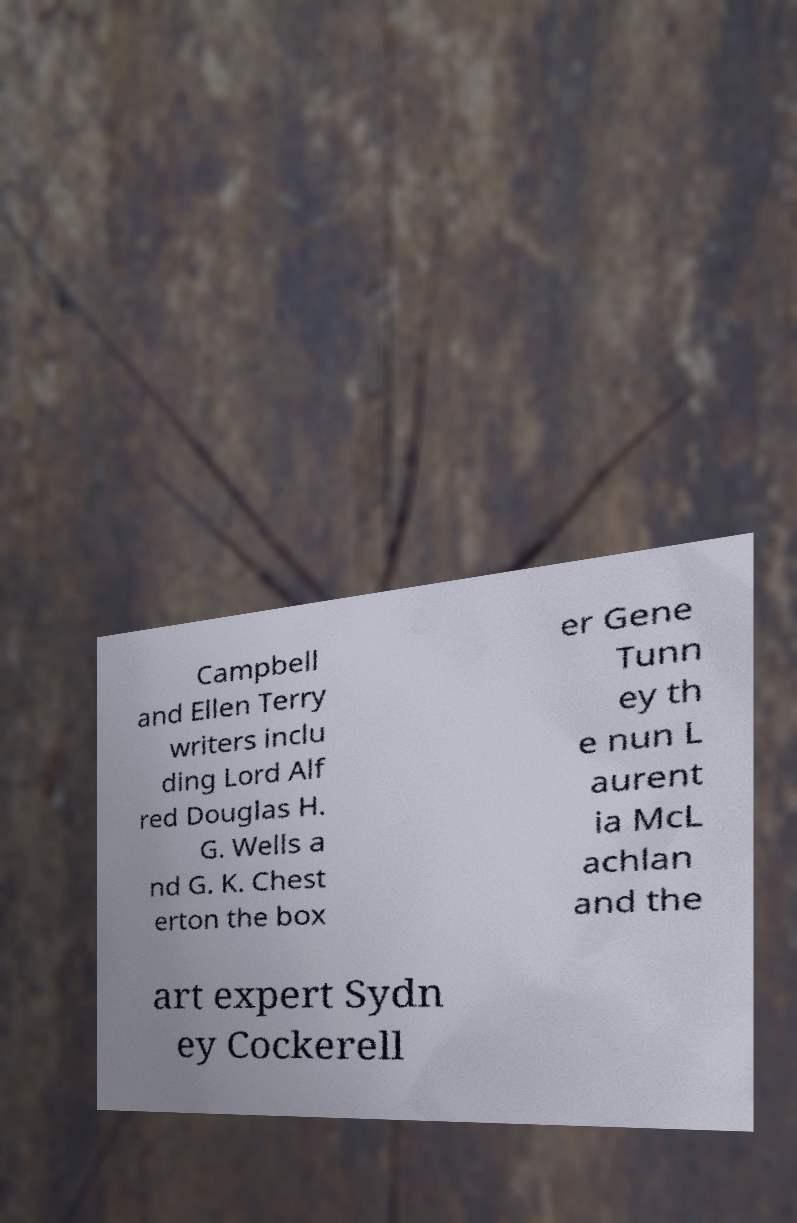I need the written content from this picture converted into text. Can you do that? Campbell and Ellen Terry writers inclu ding Lord Alf red Douglas H. G. Wells a nd G. K. Chest erton the box er Gene Tunn ey th e nun L aurent ia McL achlan and the art expert Sydn ey Cockerell 